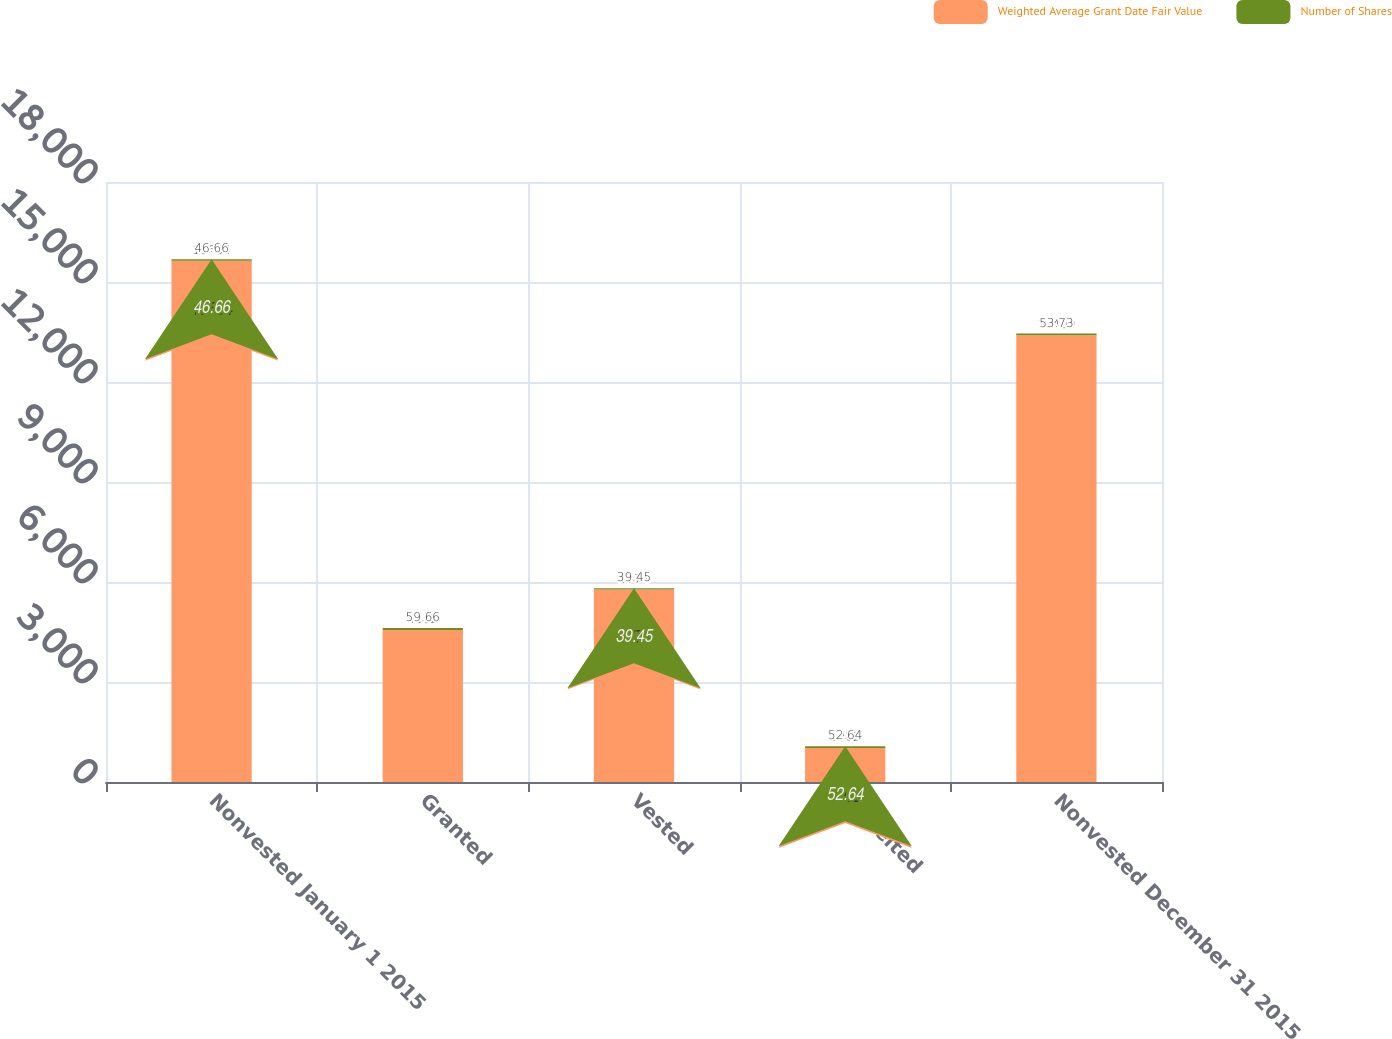Convert chart. <chart><loc_0><loc_0><loc_500><loc_500><stacked_bar_chart><ecel><fcel>Nonvested January 1 2015<fcel>Granted<fcel>Vested<fcel>Forfeited<fcel>Nonvested December 31 2015<nl><fcel>Weighted Average Grant Date Fair Value<fcel>15634<fcel>4562<fcel>5774<fcel>1022<fcel>13400<nl><fcel>Number of Shares<fcel>46.66<fcel>59.66<fcel>39.45<fcel>52.64<fcel>53.73<nl></chart> 